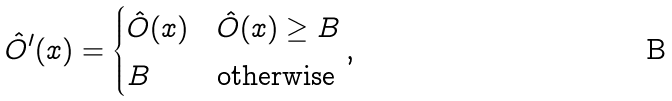Convert formula to latex. <formula><loc_0><loc_0><loc_500><loc_500>\hat { O } ^ { \prime } ( x ) = \begin{cases} \hat { O } ( x ) & \hat { O } ( x ) \geq B \\ B & \text {otherwise} \end{cases} \text {,}</formula> 